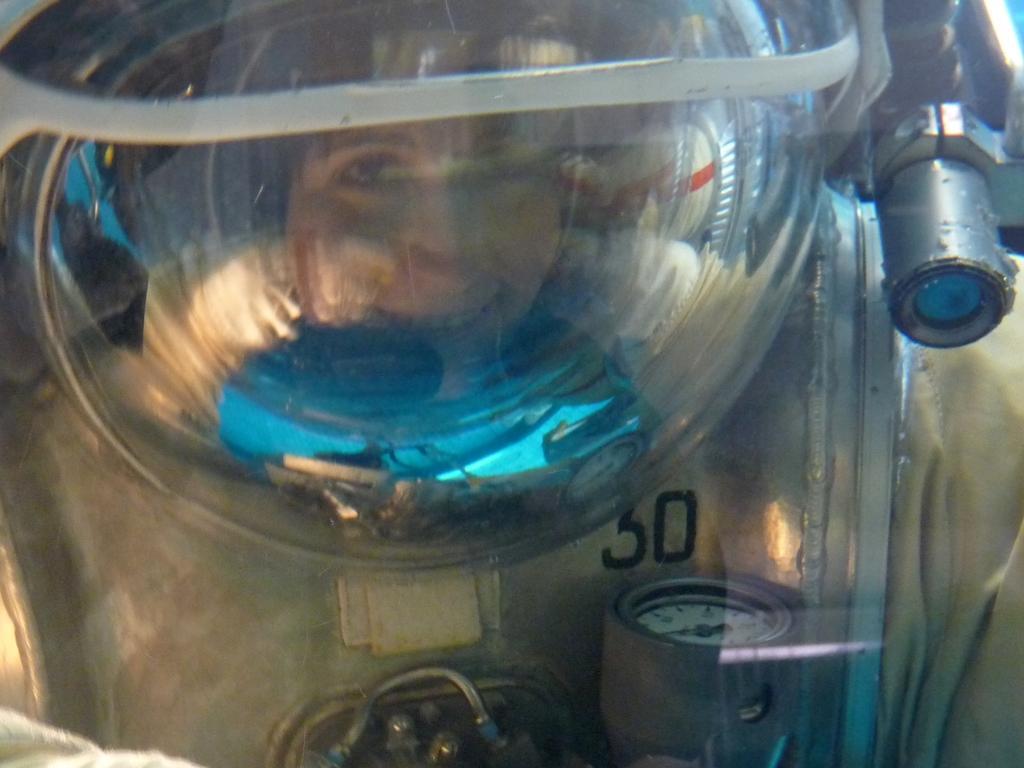Could you give a brief overview of what you see in this image? This is a zoomed in picture. In the foreground there is a person wearing helmet and some other objects and smiling. 